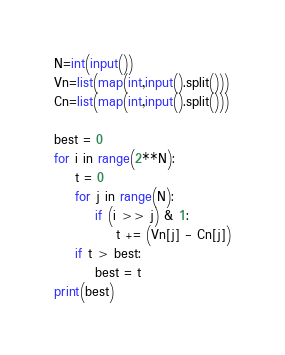Convert code to text. <code><loc_0><loc_0><loc_500><loc_500><_Python_>N=int(input())
Vn=list(map(int,input().split()))
Cn=list(map(int,input().split()))

best = 0
for i in range(2**N):
    t = 0
    for j in range(N):
        if (i >> j) & 1:
            t += (Vn[j] - Cn[j])
    if t > best:
        best = t
print(best)
</code> 